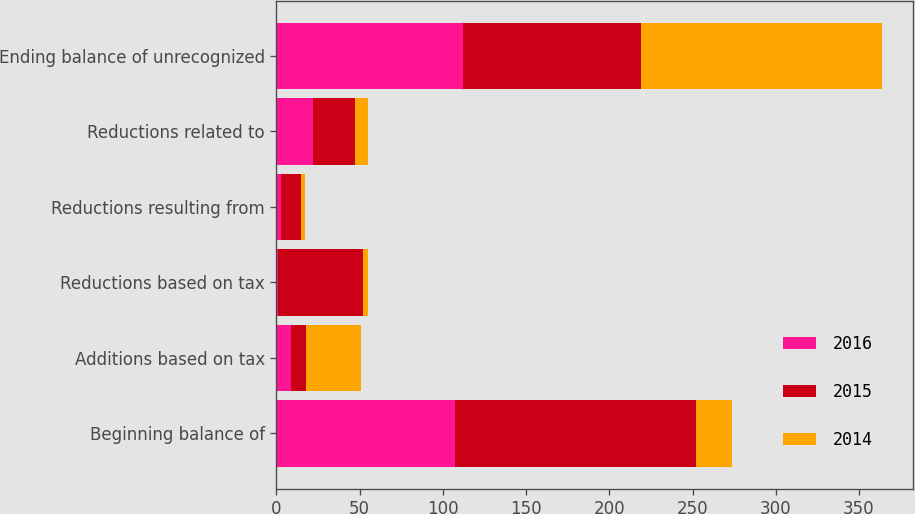Convert chart to OTSL. <chart><loc_0><loc_0><loc_500><loc_500><stacked_bar_chart><ecel><fcel>Beginning balance of<fcel>Additions based on tax<fcel>Reductions based on tax<fcel>Reductions resulting from<fcel>Reductions related to<fcel>Ending balance of unrecognized<nl><fcel>2016<fcel>107<fcel>9<fcel>1<fcel>3<fcel>22<fcel>112<nl><fcel>2015<fcel>145<fcel>9<fcel>51<fcel>12<fcel>25<fcel>107<nl><fcel>2014<fcel>22<fcel>33<fcel>3<fcel>2<fcel>8<fcel>145<nl></chart> 